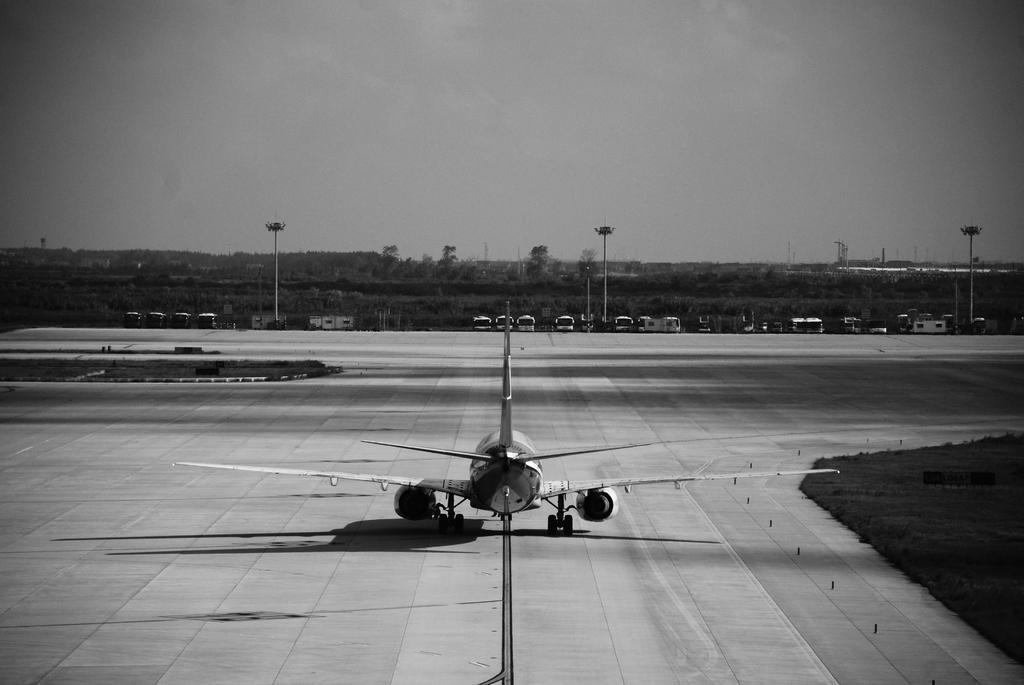In one or two sentences, can you explain what this image depicts? This image is a black and white image. This image is taken outdoors. At the top of the image there is a sky with clouds. At the bottom of the image there is a runway. In the middle of the image there is an airplane on the runway. On the right side of the image there is a ground. In the background there are a few trees and plants. There are a few poles and a few vehicles are parked on the ground. 